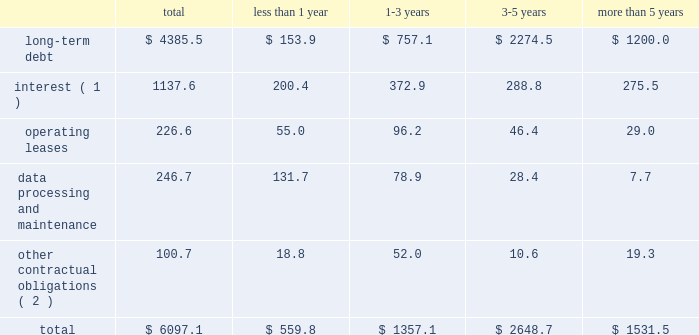Contractual obligations fis 2019 long-term contractual obligations generally include its long-term debt , interest on long-term debt , lease payments on certain of its property and equipment and payments for data processing and maintenance .
For more descriptive information regarding the company's long-term debt , see note 13 in the notes to consolidated financial statements .
The table summarizes fis 2019 significant contractual obligations and commitments as of december 31 , 2012 ( in millions ) : less than 1-3 3-5 more than total 1 year years years 5 years .
( 1 ) these calculations assume that : ( a ) applicable margins remain constant ; ( b ) all variable rate debt is priced at the one-month libor rate in effect as of december 31 , 2012 ; ( c ) no new hedging transactions are effected ; ( d ) only mandatory debt repayments are made ; and ( e ) no refinancing occurs at debt maturity .
( 2 ) amount includes the payment for labor claims related to fis' former item processing and remittance operations in brazil ( see note 3 to the consolidated financial statements ) and amounts due to the brazilian venture partner .
Fis believes that its existing cash balances , cash flows from operations and borrowing programs will provide adequate sources of liquidity and capital resources to meet fis 2019 expected short-term liquidity needs and its long-term needs for the operations of its business , expected capital spending for the next 12 months and the foreseeable future and the satisfaction of these obligations and commitments .
Off-balance sheet arrangements fis does not have any off-balance sheet arrangements .
Item 7a .
Quantitative and qualitative disclosure about market risks market risk we are exposed to market risks primarily from changes in interest rates and foreign currency exchange rates .
We use certain derivative financial instruments , including interest rate swaps and foreign currency forward exchange contracts , to manage interest rate and foreign currency risk .
We do not use derivatives for trading purposes , to generate income or to engage in speculative activity .
Interest rate risk in addition to existing cash balances and cash provided by operating activities , we use fixed rate and variable rate debt to finance our operations .
We are exposed to interest rate risk on these debt obligations and related interest rate swaps .
The notes ( as defined in note 13 to the consolidated financial statements ) represent substantially all of our fixed-rate long-term debt obligations .
The carrying value of the notes was $ 1950.0 million as of december 31 , 2012 .
The fair value of the notes was approximately $ 2138.2 million as of december 31 , 2012 .
The potential reduction in fair value of the notes from a hypothetical 10 percent increase in market interest rates would not be material to the overall fair value of the debt .
Our floating rate long-term debt obligations principally relate to borrowings under the fis credit agreement ( as also defined in note 13 to the consolidated financial statements ) .
An increase of 100 basis points in the libor rate would increase our annual debt service under the fis credit agreement , after we include the impact of our interest rate swaps , by $ 9.3 million ( based on principal amounts outstanding as of december 31 , 2012 ) .
We performed the foregoing sensitivity analysis based on the principal amount of our floating rate debt as of december 31 , 2012 , less the principal amount of such debt that was then subject to an interest rate swap converting such debt into fixed rate debt .
This sensitivity analysis is based solely on .
What portion of the total contractual obligations are related to long-term debt? 
Computations: (4385.5 / 6097.1)
Answer: 0.71928. 